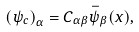<formula> <loc_0><loc_0><loc_500><loc_500>\left ( \psi _ { c } \right ) _ { \alpha } = C _ { \alpha \beta } \bar { \psi } _ { \beta } ( x ) ,</formula> 